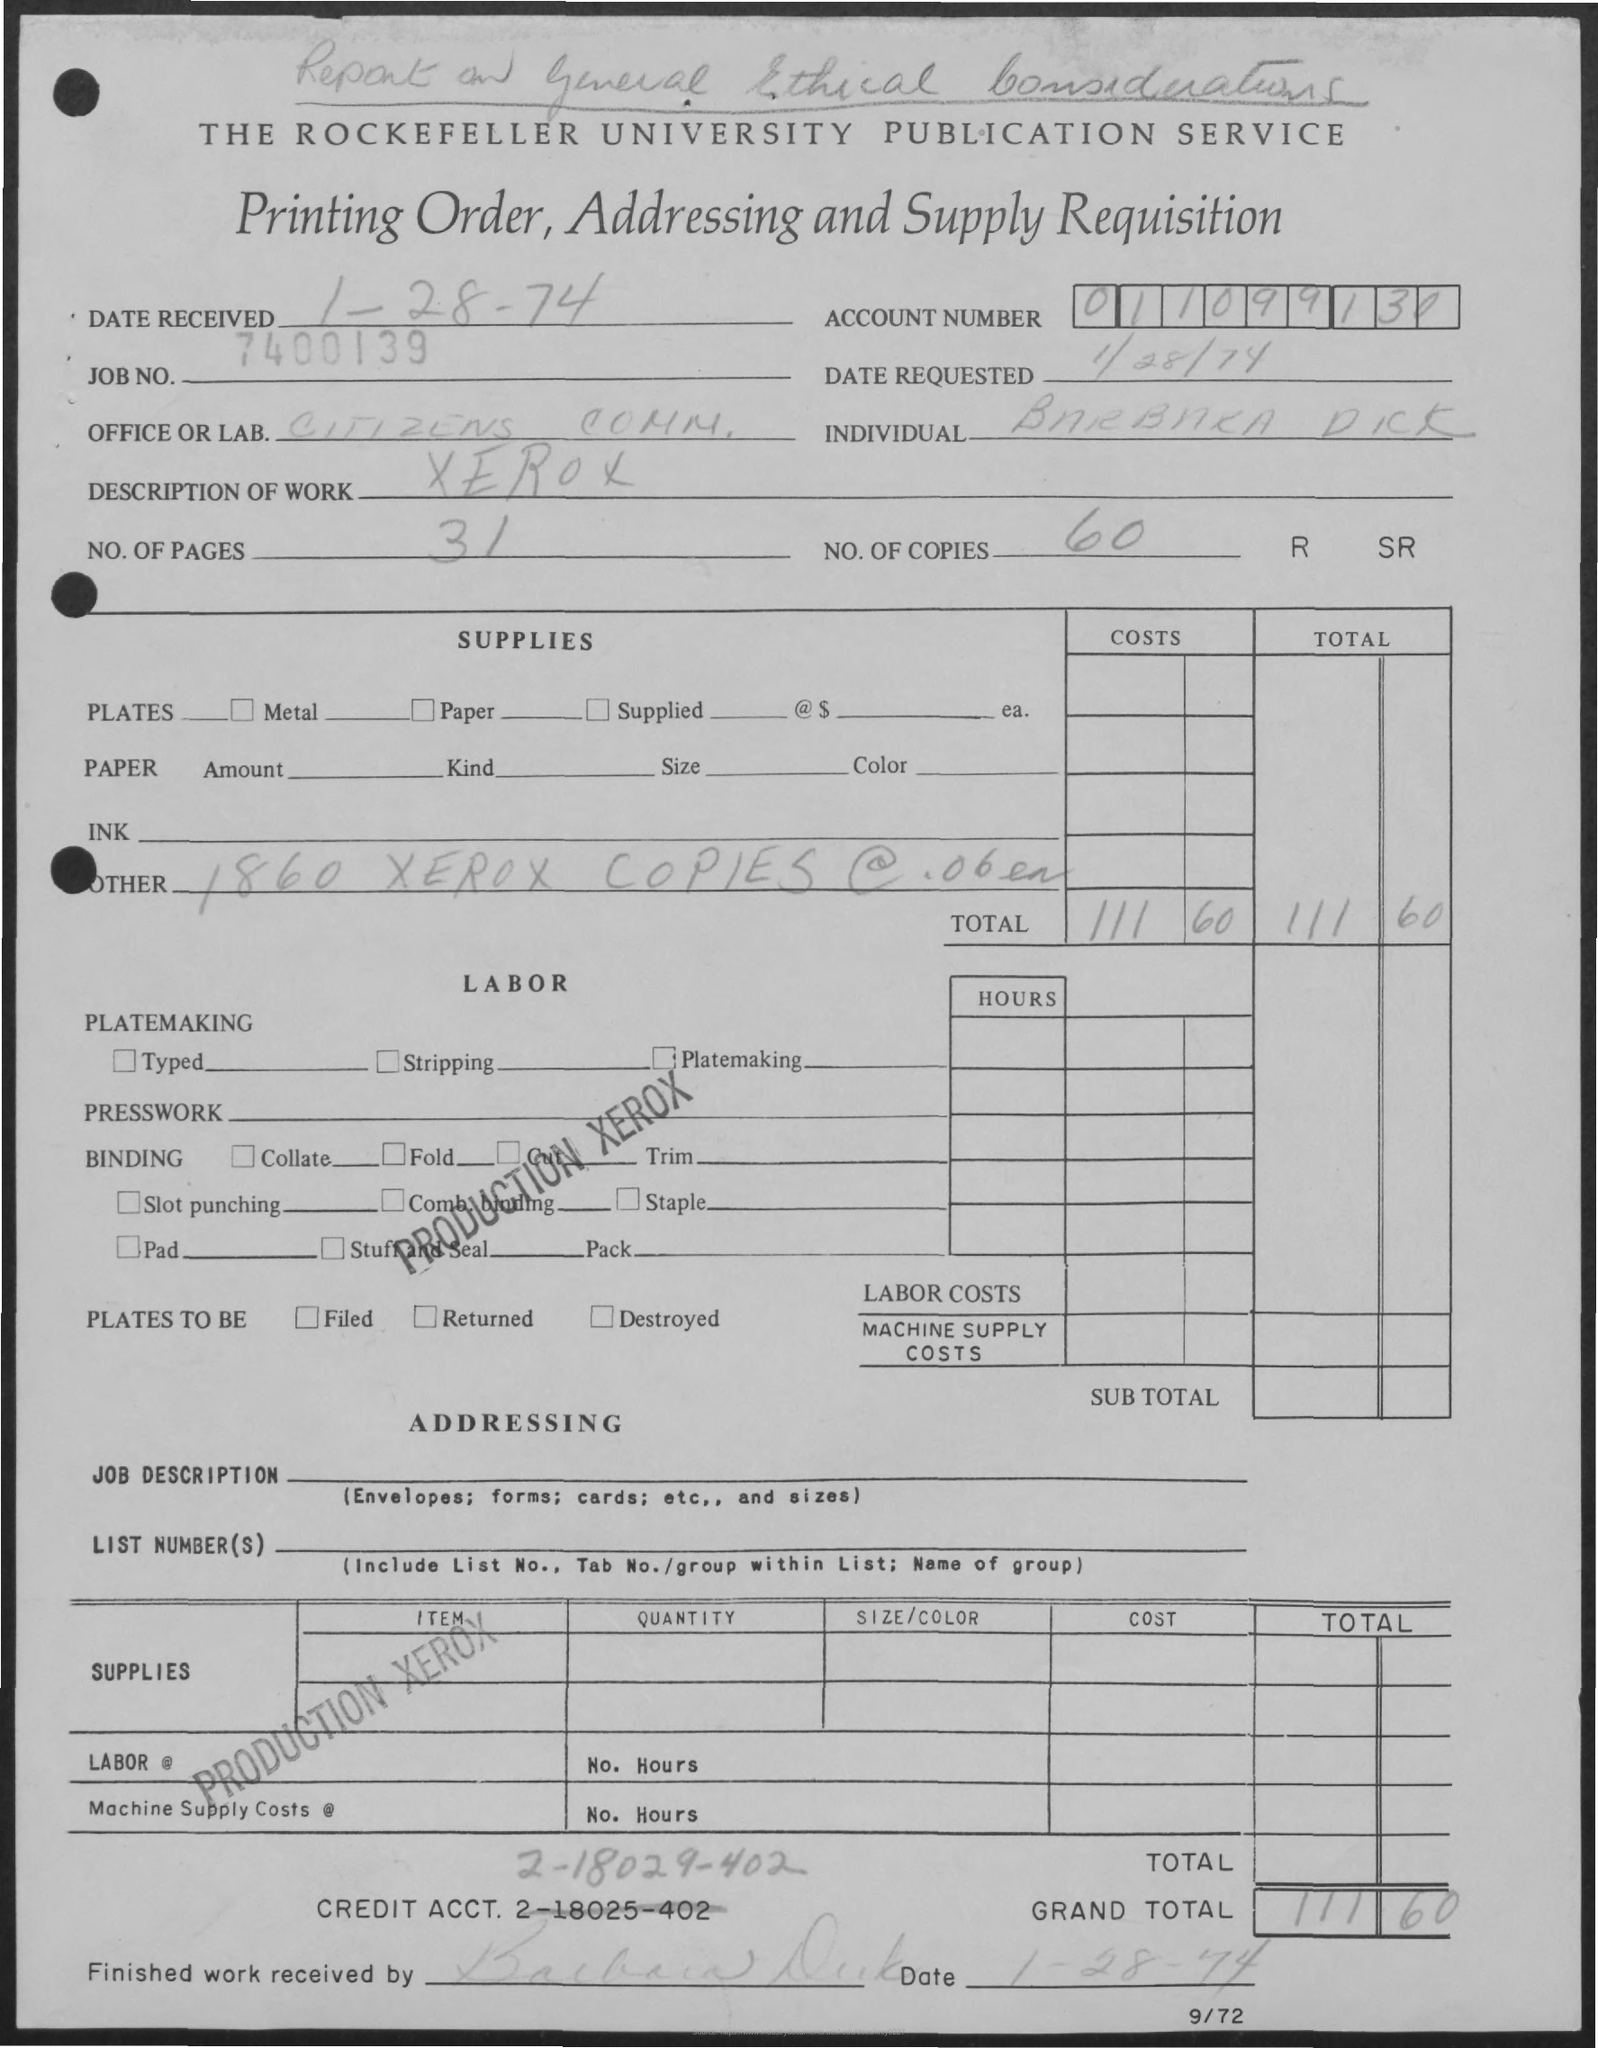What is the total cost for the copies made? The total cost for the copies made is marked as $11.60, which is calculated from the 460 Xerox copies produced at a rate of 0.6 cents each. How do you determine the cost per copy from this information? The cost per copy can be determined by taking the total number of copies (460) and noting that they were made at a rate of 0.6 cents each, as indicated on the form under 'Supplies.' Multiplying the two gives the total cost. 